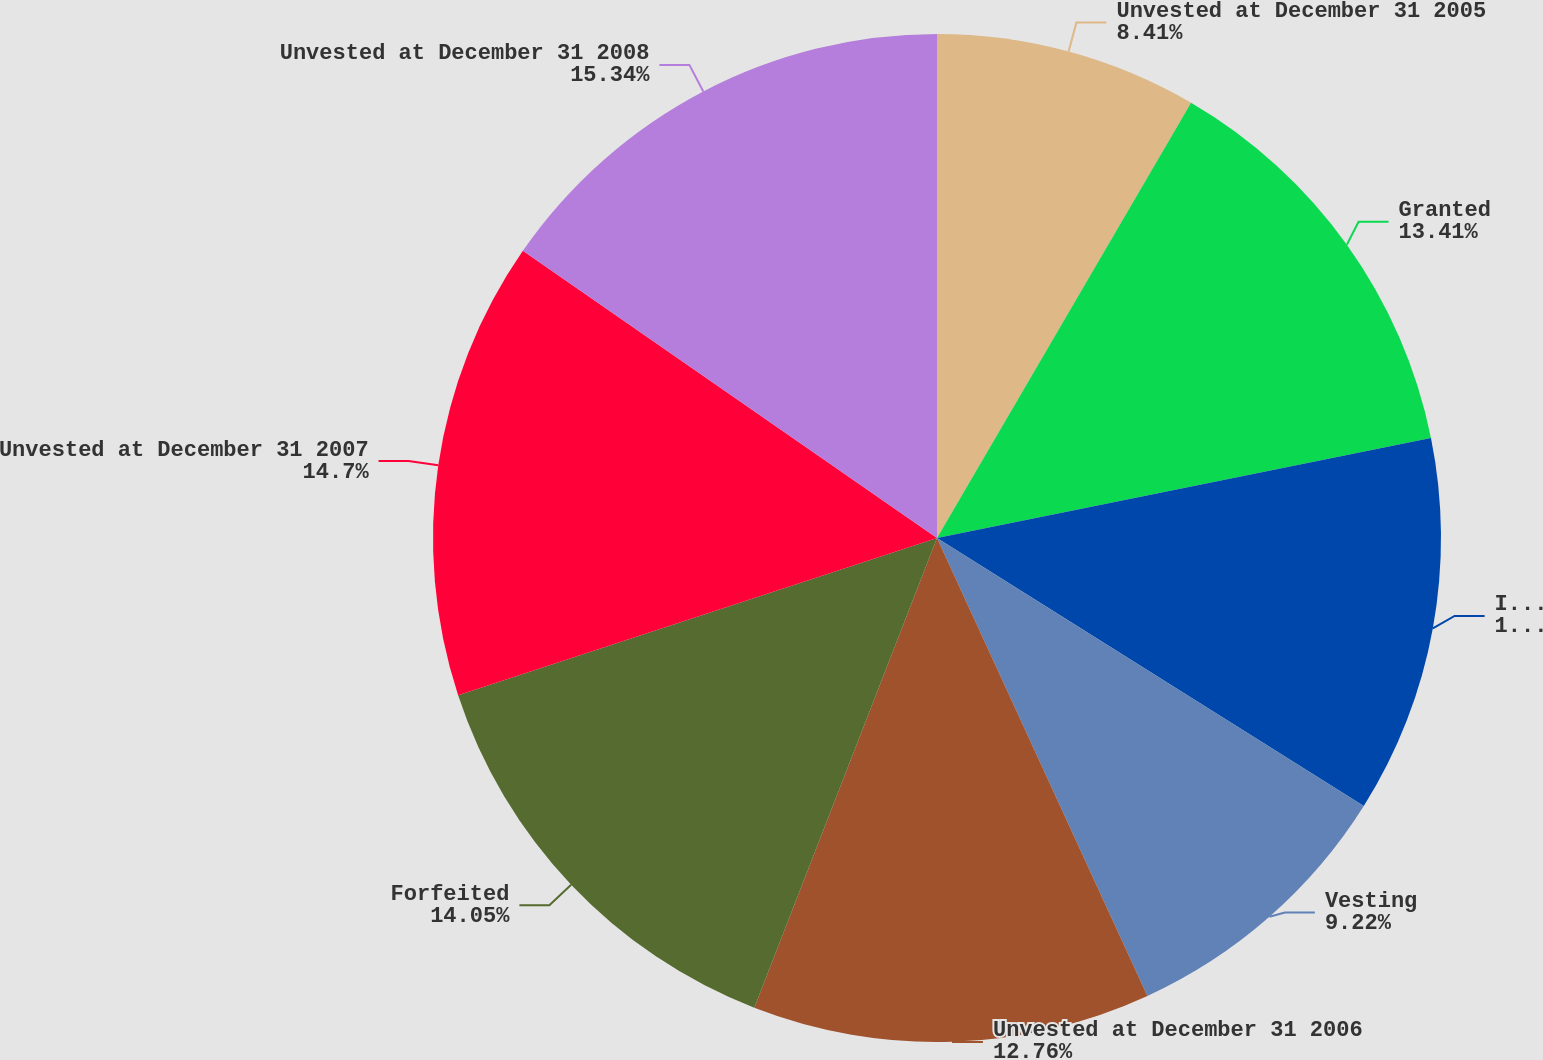Convert chart to OTSL. <chart><loc_0><loc_0><loc_500><loc_500><pie_chart><fcel>Unvested at December 31 2005<fcel>Granted<fcel>Issued in connection with<fcel>Vesting<fcel>Unvested at December 31 2006<fcel>Forfeited<fcel>Unvested at December 31 2007<fcel>Unvested at December 31 2008<nl><fcel>8.41%<fcel>13.41%<fcel>12.11%<fcel>9.22%<fcel>12.76%<fcel>14.05%<fcel>14.7%<fcel>15.35%<nl></chart> 